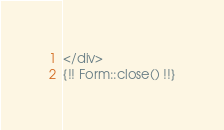<code> <loc_0><loc_0><loc_500><loc_500><_PHP_></div>
{!! Form::close() !!}
</code> 